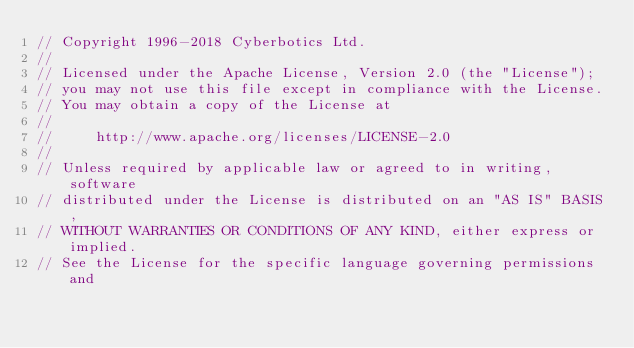<code> <loc_0><loc_0><loc_500><loc_500><_C++_>// Copyright 1996-2018 Cyberbotics Ltd.
//
// Licensed under the Apache License, Version 2.0 (the "License");
// you may not use this file except in compliance with the License.
// You may obtain a copy of the License at
//
//     http://www.apache.org/licenses/LICENSE-2.0
//
// Unless required by applicable law or agreed to in writing, software
// distributed under the License is distributed on an "AS IS" BASIS,
// WITHOUT WARRANTIES OR CONDITIONS OF ANY KIND, either express or implied.
// See the License for the specific language governing permissions and</code> 